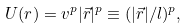<formula> <loc_0><loc_0><loc_500><loc_500>U ( r ) = v ^ { p } | \vec { r } | ^ { p } \equiv ( | \vec { r } | / l ) ^ { p } ,</formula> 